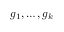<formula> <loc_0><loc_0><loc_500><loc_500>g _ { 1 } , \dots , g _ { k }</formula> 